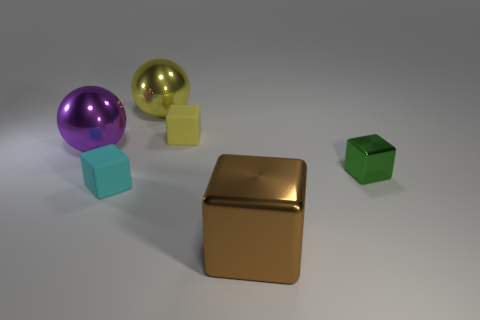Add 2 tiny shiny blocks. How many objects exist? 8 Subtract all large blocks. How many blocks are left? 3 Subtract all cyan blocks. How many blocks are left? 3 Subtract all spheres. How many objects are left? 4 Subtract 3 cubes. How many cubes are left? 1 Subtract all red balls. Subtract all purple cylinders. How many balls are left? 2 Subtract all blue cubes. How many purple balls are left? 1 Subtract all big purple balls. Subtract all yellow metallic objects. How many objects are left? 4 Add 1 large blocks. How many large blocks are left? 2 Add 1 yellow matte things. How many yellow matte things exist? 2 